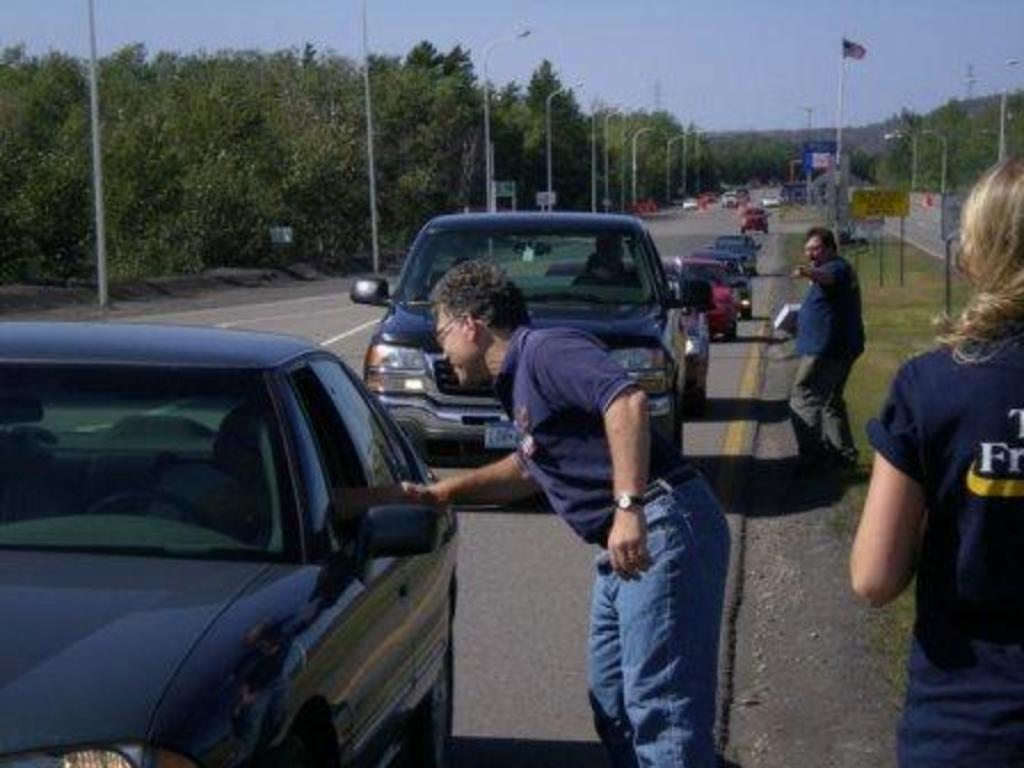What is happening on the road in the image? There are cars on a road in the image. Are there any people present near the road? Yes, there are three persons standing beside the road. What can be seen on either side of the road? There are poles on either side of the road. What is visible in the background of the image? Trees and the sky are visible in the background of the image. What type of error can be seen on the cars in the image? There is no error visible on the cars in the image; they appear to be functioning properly. 